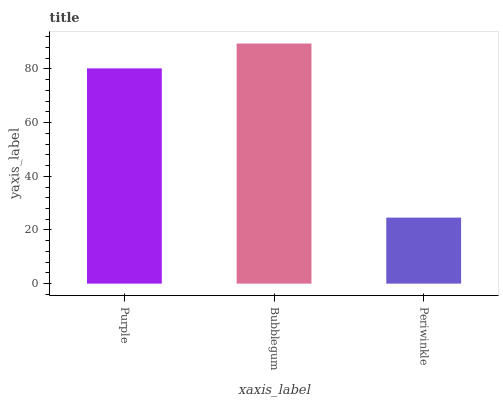Is Periwinkle the minimum?
Answer yes or no. Yes. Is Bubblegum the maximum?
Answer yes or no. Yes. Is Bubblegum the minimum?
Answer yes or no. No. Is Periwinkle the maximum?
Answer yes or no. No. Is Bubblegum greater than Periwinkle?
Answer yes or no. Yes. Is Periwinkle less than Bubblegum?
Answer yes or no. Yes. Is Periwinkle greater than Bubblegum?
Answer yes or no. No. Is Bubblegum less than Periwinkle?
Answer yes or no. No. Is Purple the high median?
Answer yes or no. Yes. Is Purple the low median?
Answer yes or no. Yes. Is Periwinkle the high median?
Answer yes or no. No. Is Periwinkle the low median?
Answer yes or no. No. 